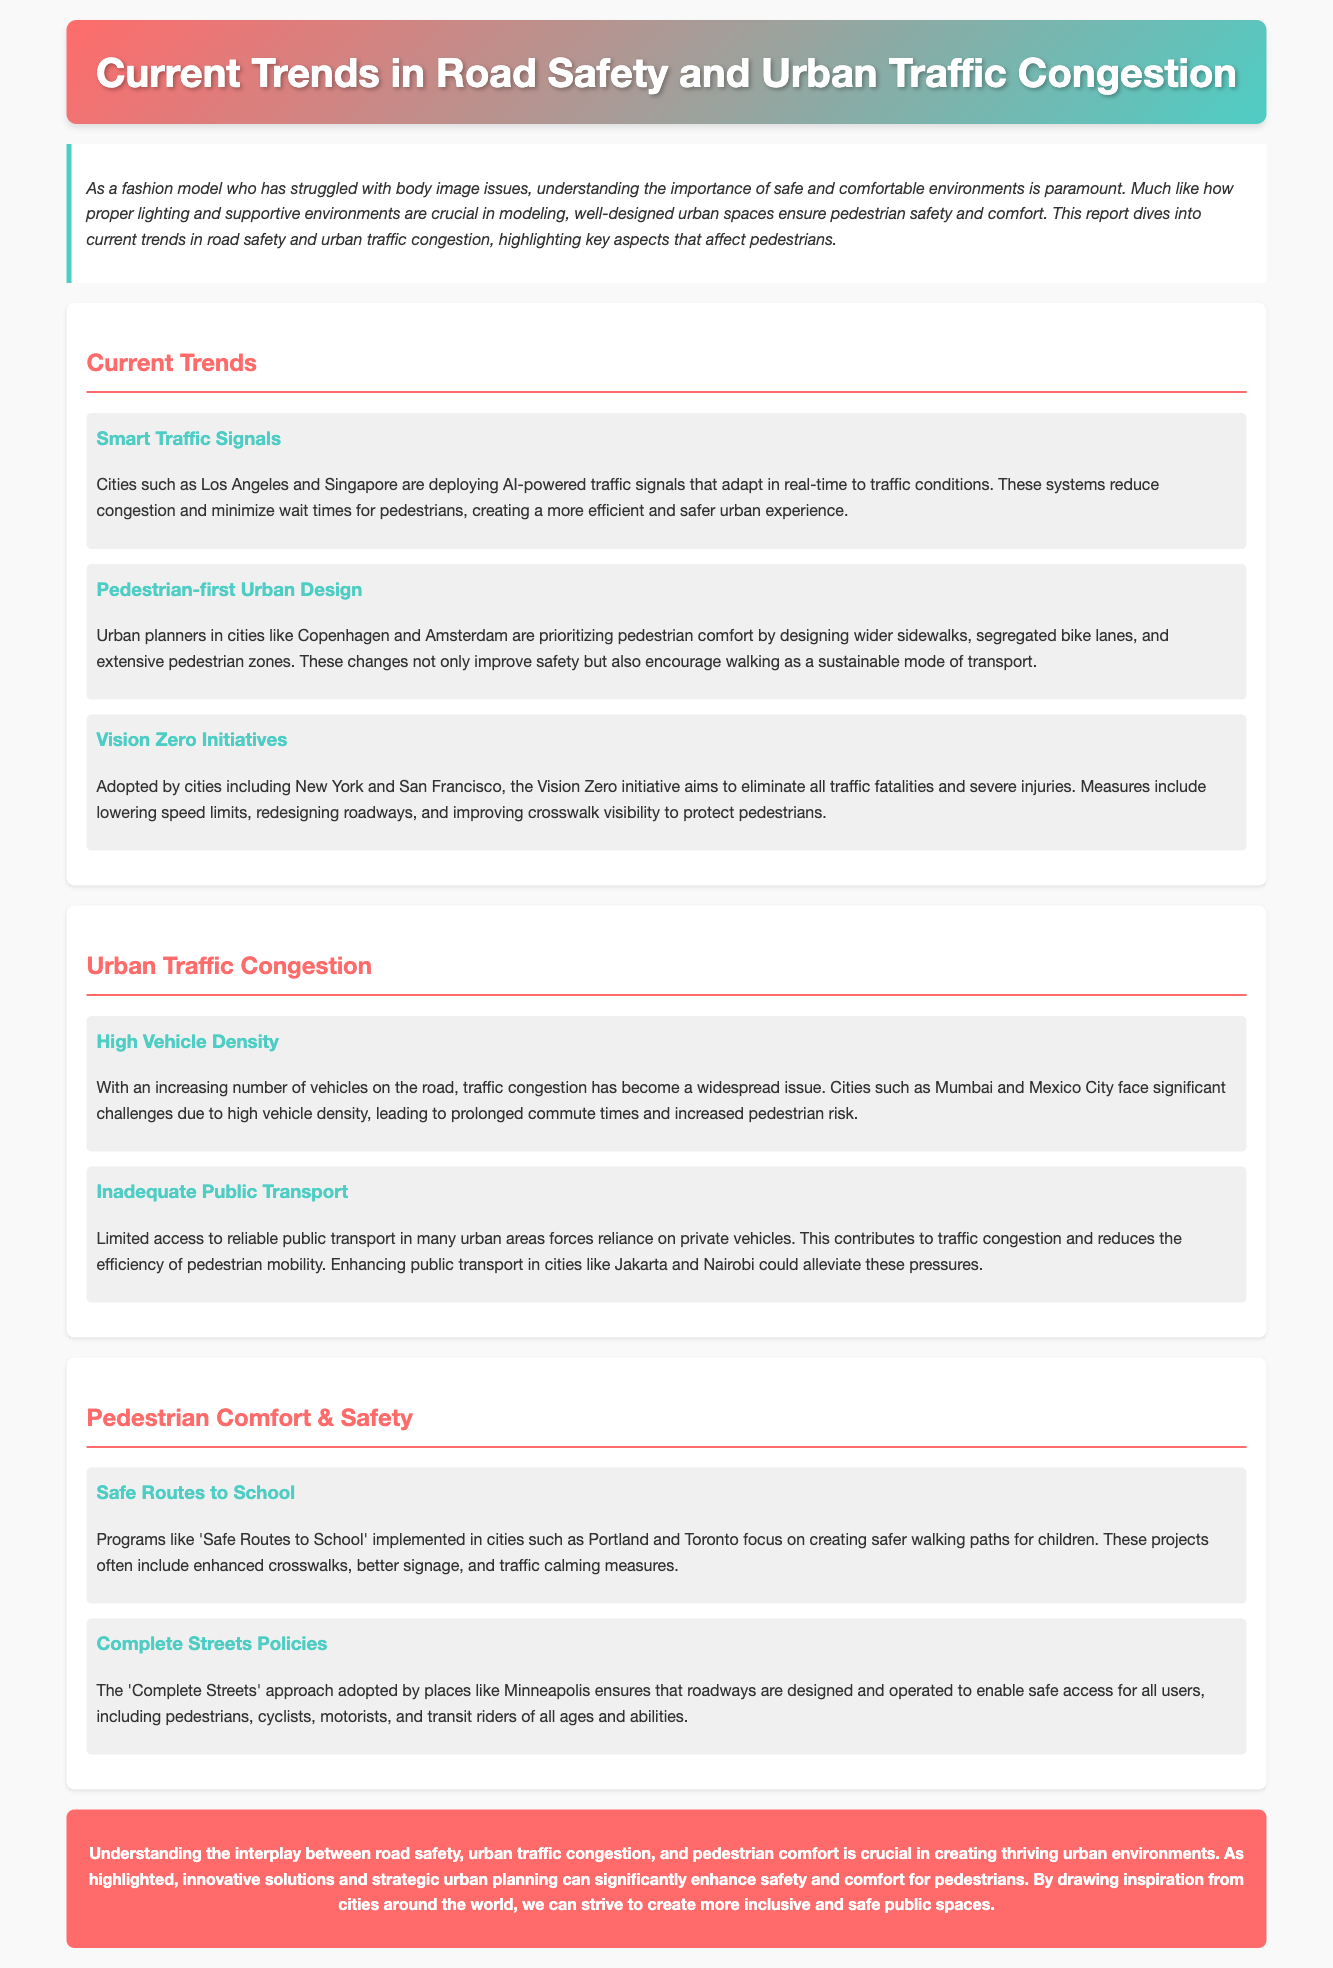What are cities deploying to manage traffic signals? The document states that cities such as Los Angeles and Singapore are deploying AI-powered traffic signals.
Answer: AI-powered traffic signals What initiative aims to eliminate all traffic fatalities? The Vision Zero initiative is aimed at that goal, as mentioned in the report.
Answer: Vision Zero Which cities prioritize pedestrian comfort in urban design? The document highlights Copenhagen and Amsterdam as cities focusing on pedestrian comfort.
Answer: Copenhagen and Amsterdam What is a major cause of urban traffic congestion? High vehicle density is identified as a significant cause of congestion in the report.
Answer: High vehicle density What program focuses on safer walking paths for children? The 'Safe Routes to School' program is mentioned as a key initiative for children's safety.
Answer: Safe Routes to School What approach does Minneapolis adopt for roadway design? The 'Complete Streets' approach is specified in the context of Minneapolis.
Answer: Complete Streets How do smart traffic signals enhance pedestrian experience? They adapt in real-time to traffic conditions, reducing congestion and wait times for pedestrians.
Answer: Reducing congestion and wait times What do inadequate public transport systems contribute to? They contribute to reliance on private vehicles and increased traffic congestion.
Answer: Increased traffic congestion What is the purpose of enhanced crosswalks in pedestrian initiatives? Enhanced crosswalks aim to improve safety for pedestrians, especially children.
Answer: Improve safety for pedestrians 